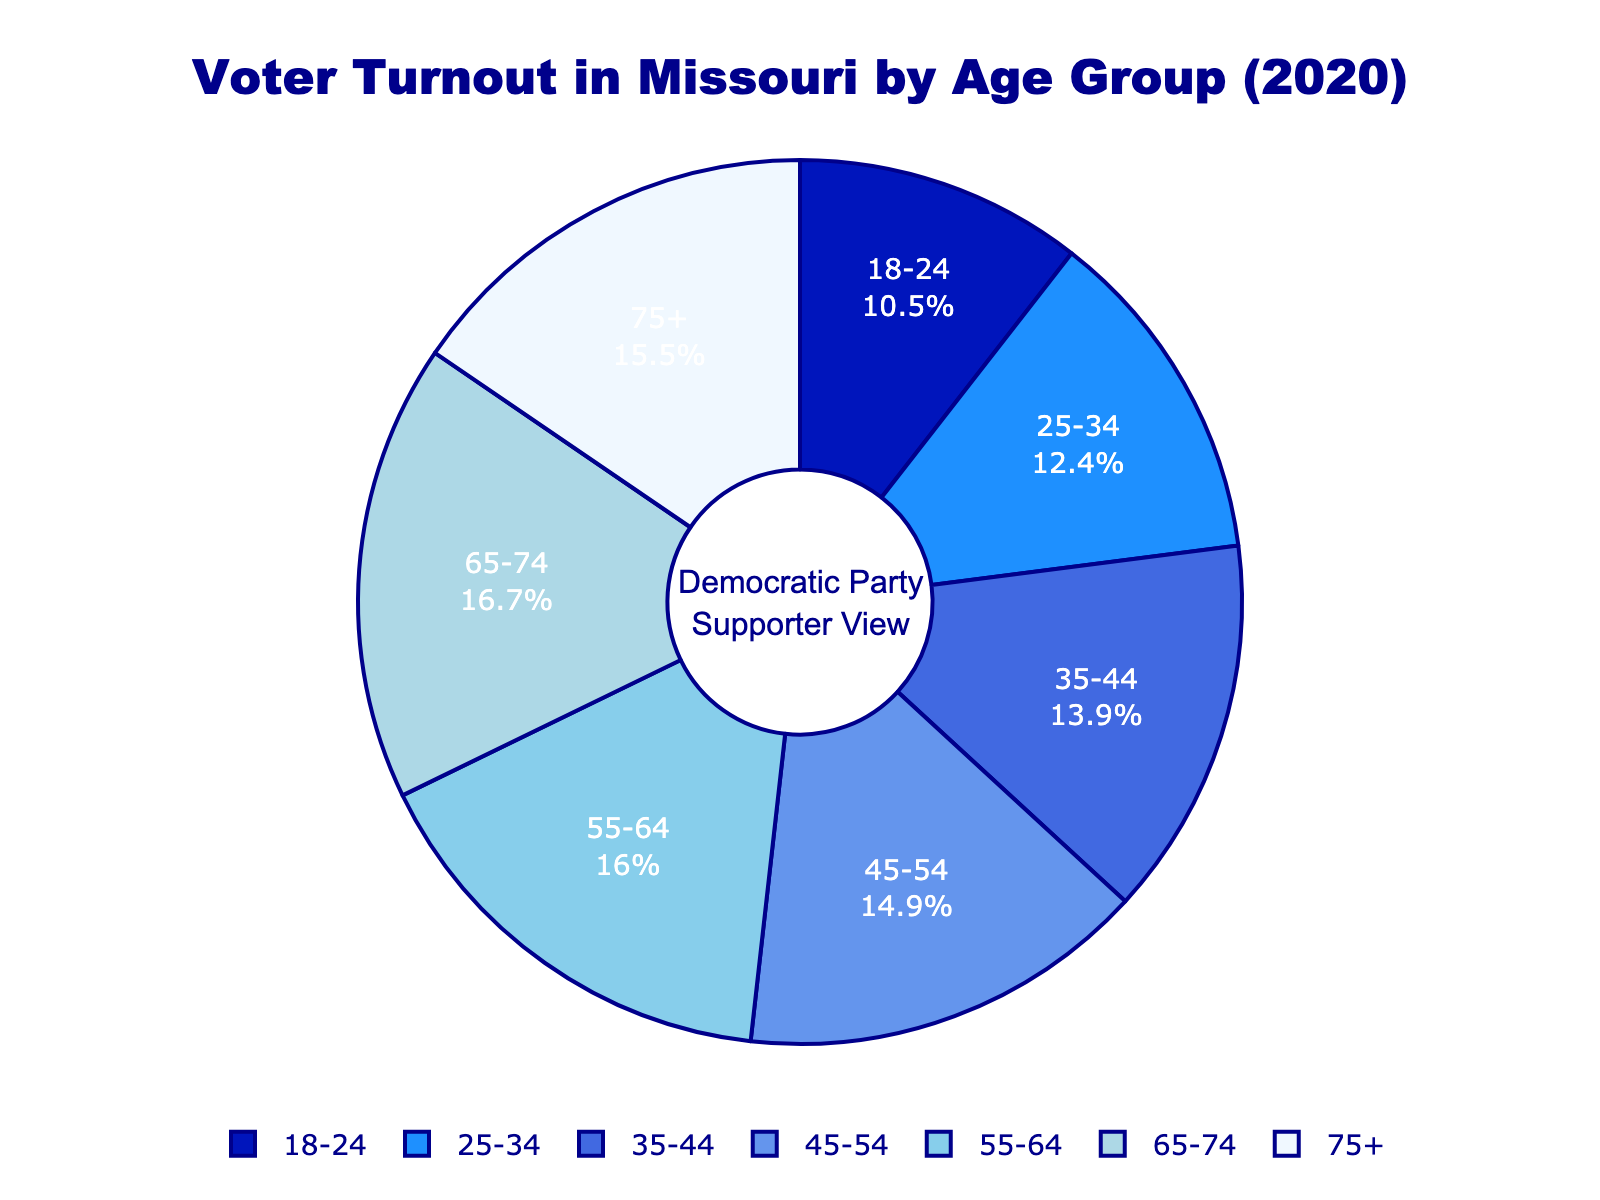Which age group has the highest voter turnout percentage? By examining the pie chart, the 65-74 age group has the highest segment of the pie, indicating the highest percentage.
Answer: 65-74 How does the voter turnout percentage of the 18-24 age group compare to the 75+ age group? The 18-24 age group has a voter turnout of 52.3%, while the 75+ age group has a turnout of 76.8%. Thus, the 75+ age group has a higher turnout.
Answer: 75+ has a higher turnout Which age group has a turnout percentage below 60%? From the chart, the 18-24 age group is the only one with a voter turnout below 60%, specifically 52.3%.
Answer: 18-24 What is the difference in voter turnout percentage between the 55-64 and 35-44 age groups? The voter turnout for the 55-64 age group is 79.5% and for the 35-44 age group is 68.9%. Subtracting these gives 79.5% - 68.9% = 10.6%.
Answer: 10.6% What is the average voter turnout percentage for the 45-54, 55-64, and 65-74 age groups? The voter turnouts are 74.2%, 79.5%, and 83.1%. Adding these gives 74.2 + 79.5 + 83.1 = 236.8. Dividing by 3, the average is 236.8 / 3 ≈ 78.93%.
Answer: 78.93% Which age group shows the biggest increase in voter turnout percentage compared to the previous age group? Comparing each consecutive pair, the largest increase is between the 18-24 group (52.3%) and the 25-34 group (61.7%), an increase of 9.4%.
Answer: 25-34 How does the voter turnout percentage for the 35-44 age group compare to the 45-54 age group? The voter turnout for the 35-44 age group is 68.9%, while it's 74.2% for the 45-54 age group. The 45-54 group has a higher turnout.
Answer: 45-54 has a higher turnout What is the combined voter turnout percentage for the age groups 65-74 and 75+? The voter turnout percentage for 65-74 is 83.1% and for 75+ is 76.8%. Adding these percentages gives 83.1 + 76.8 = 159.9%.
Answer: 159.9% 